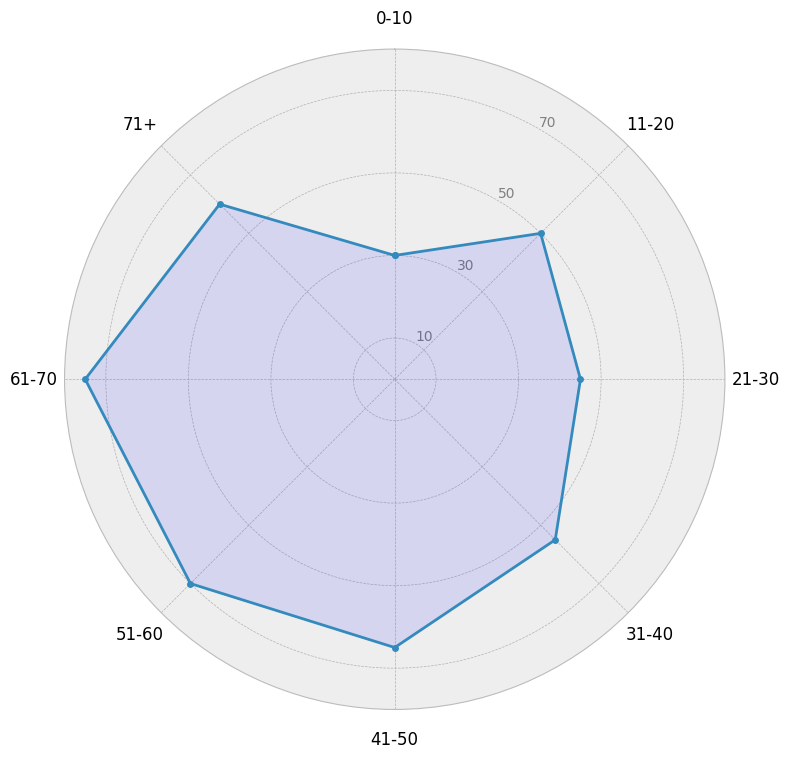What's the average use of local dialects across all age groups? To find the average, sum the usage values for all age groups and divide by the number of age groups. The values are 30, 50, 45, 55, 65, 70, 75, and 60. The sum is 450. There are 8 age groups, so the average is 450 / 8 = 56.25
Answer: 56.25 Which age group has the highest use of local dialects? Look for the highest point on the radar chart. The highest value is 75, which corresponds to the 61-70 age group
Answer: 61-70 Which age groups have a use of local dialects higher than 60? Identify the age groups with values above 60. They are 41-50 (65), 51-60 (70), and 61-70 (75)
Answer: 41-50, 51-60, 61-70 What is the difference in the use of local dialects between the youngest (0-10) and the oldest (71+) age groups? Subtract the value for the 0-10 age group (30) from the value for the 71+ age group (60). The difference is 60 - 30 = 30
Answer: 30 Which two consecutive age groups have the largest increase in the use of local dialects? Compare the differences between consecutive age groups: 11-20 - 0-10 = 20, 21-30 - 11-20 = -5, 31-40 - 21-30 = 10, 41-50 - 31-40 = 10, 51-60 - 41-50 = 5, 61-70 - 51-60 = 5, and 71+ - 61-70 = -15. The largest increase is 20 between 0-10 and 11-20
Answer: 0-10 and 11-20 What is the median use value of local dialects across all age groups? Arrange the values in ascending order: 30, 45, 50, 55, 60, 65, 70, 75. The median is the average of the 4th and 5th values (55 and 60): median = (55 + 60) / 2 = 57.5
Answer: 57.5 How does the use of local dialects among the 31-40 age group compare to the 51-60 age group? Compare the values directly: 31-40 (55) and 51-60 (70). The value is higher in the 51-60 age group
Answer: Higher in the 51-60 group What's the range of the use of local dialects across all age groups? Subtract the smallest value (30) from the largest value (75) to get the range: range = 75 - 30 = 45
Answer: 45 Which age group shows a decline in the use of local dialects compared to its previous age group? Compare each age group's use to the one before. The 21-30 age group (45) shows a decline from the 11-20 age group (50)
Answer: 21-30 